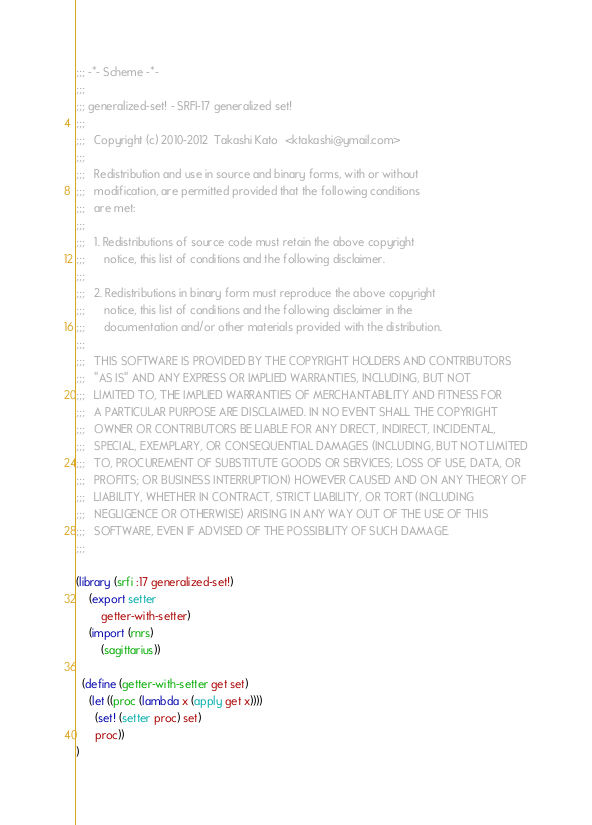Convert code to text. <code><loc_0><loc_0><loc_500><loc_500><_Scheme_>;;; -*- Scheme -*-
;;;
;;; generalized-set! - SRFI-17 generalized set!
;;;  
;;;   Copyright (c) 2010-2012  Takashi Kato  <ktakashi@ymail.com>
;;;   
;;;   Redistribution and use in source and binary forms, with or without
;;;   modification, are permitted provided that the following conditions
;;;   are met:
;;;   
;;;   1. Redistributions of source code must retain the above copyright
;;;      notice, this list of conditions and the following disclaimer.
;;;  
;;;   2. Redistributions in binary form must reproduce the above copyright
;;;      notice, this list of conditions and the following disclaimer in the
;;;      documentation and/or other materials provided with the distribution.
;;;  
;;;   THIS SOFTWARE IS PROVIDED BY THE COPYRIGHT HOLDERS AND CONTRIBUTORS
;;;   "AS IS" AND ANY EXPRESS OR IMPLIED WARRANTIES, INCLUDING, BUT NOT
;;;   LIMITED TO, THE IMPLIED WARRANTIES OF MERCHANTABILITY AND FITNESS FOR
;;;   A PARTICULAR PURPOSE ARE DISCLAIMED. IN NO EVENT SHALL THE COPYRIGHT
;;;   OWNER OR CONTRIBUTORS BE LIABLE FOR ANY DIRECT, INDIRECT, INCIDENTAL,
;;;   SPECIAL, EXEMPLARY, OR CONSEQUENTIAL DAMAGES (INCLUDING, BUT NOT LIMITED
;;;   TO, PROCUREMENT OF SUBSTITUTE GOODS OR SERVICES; LOSS OF USE, DATA, OR
;;;   PROFITS; OR BUSINESS INTERRUPTION) HOWEVER CAUSED AND ON ANY THEORY OF
;;;   LIABILITY, WHETHER IN CONTRACT, STRICT LIABILITY, OR TORT (INCLUDING
;;;   NEGLIGENCE OR OTHERWISE) ARISING IN ANY WAY OUT OF THE USE OF THIS
;;;   SOFTWARE, EVEN IF ADVISED OF THE POSSIBILITY OF SUCH DAMAGE.
;;;  

(library (srfi :17 generalized-set!)
    (export setter
	    getter-with-setter)
    (import (rnrs)
	    (sagittarius))

  (define (getter-with-setter get set)
    (let ((proc (lambda x (apply get x))))
      (set! (setter proc) set)
      proc))
)</code> 